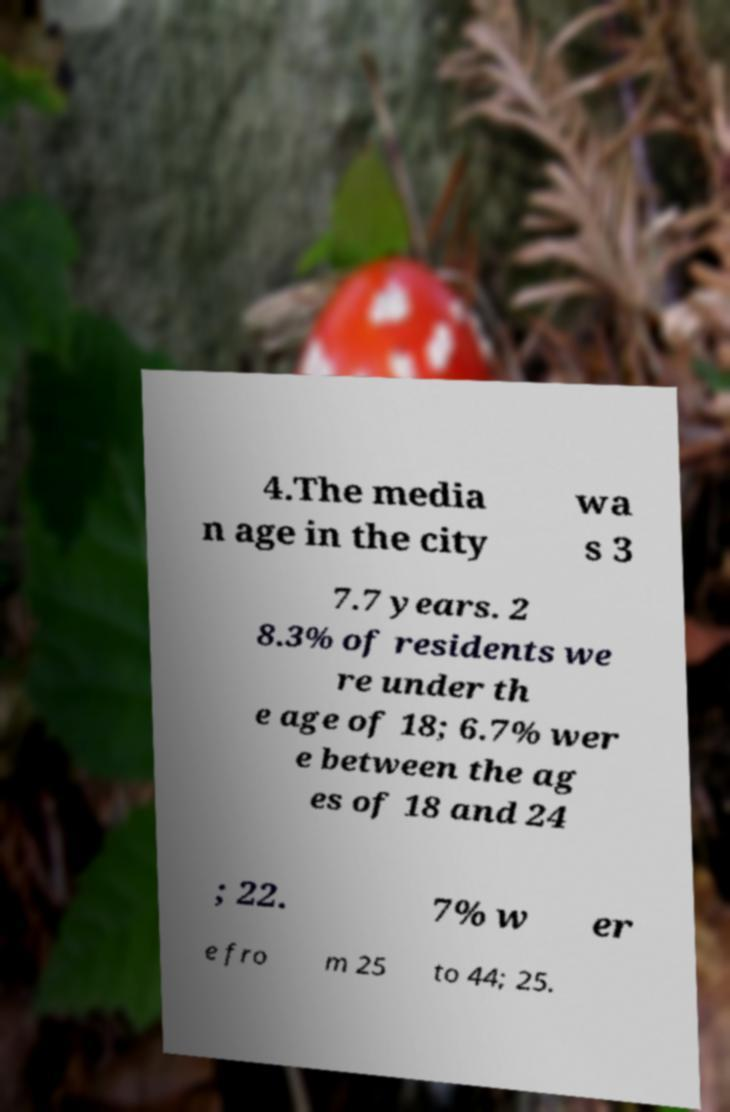Can you read and provide the text displayed in the image?This photo seems to have some interesting text. Can you extract and type it out for me? 4.The media n age in the city wa s 3 7.7 years. 2 8.3% of residents we re under th e age of 18; 6.7% wer e between the ag es of 18 and 24 ; 22. 7% w er e fro m 25 to 44; 25. 